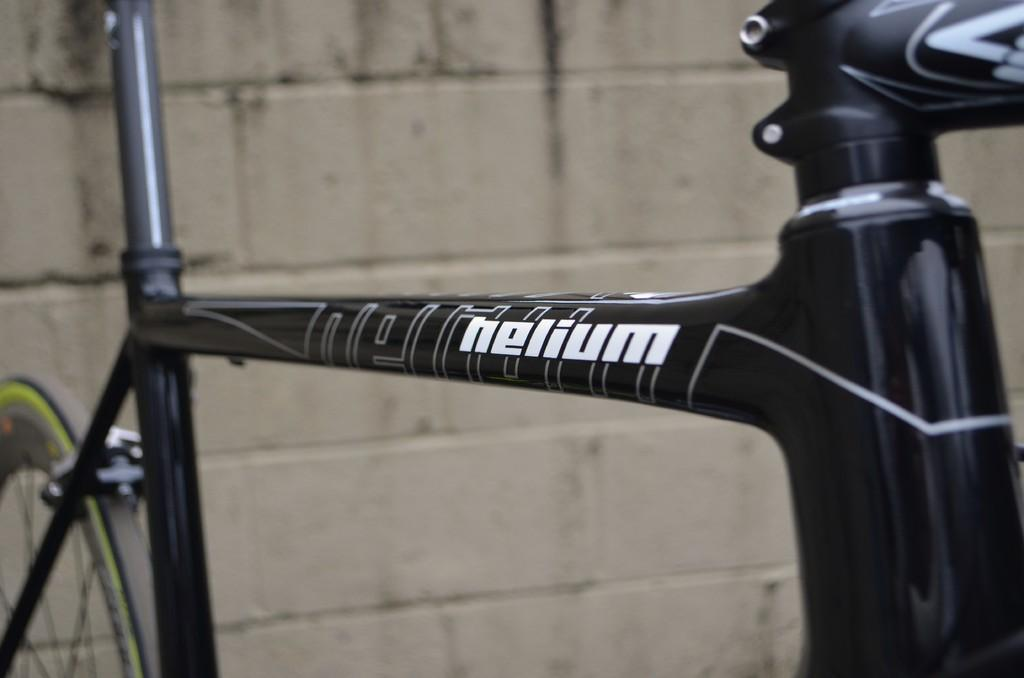What is the main object in the image? There is a bicycle in the image. What can be seen in the background of the image? There is a wall in the background of the image. What type of card is being used to decorate the bicycle in the image? There is no card present in the image; it features a bicycle and a wall in the background. 